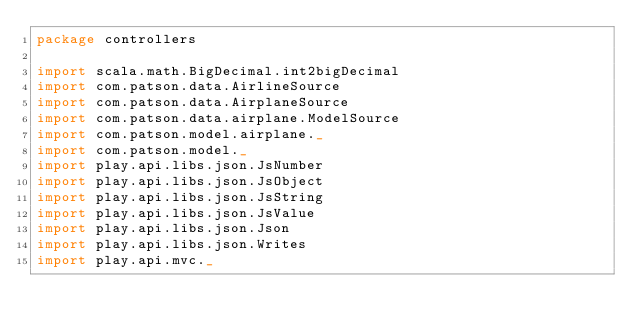<code> <loc_0><loc_0><loc_500><loc_500><_Scala_>package controllers

import scala.math.BigDecimal.int2bigDecimal
import com.patson.data.AirlineSource
import com.patson.data.AirplaneSource
import com.patson.data.airplane.ModelSource
import com.patson.model.airplane._
import com.patson.model._
import play.api.libs.json.JsNumber
import play.api.libs.json.JsObject
import play.api.libs.json.JsString
import play.api.libs.json.JsValue
import play.api.libs.json.Json
import play.api.libs.json.Writes
import play.api.mvc._
</code> 